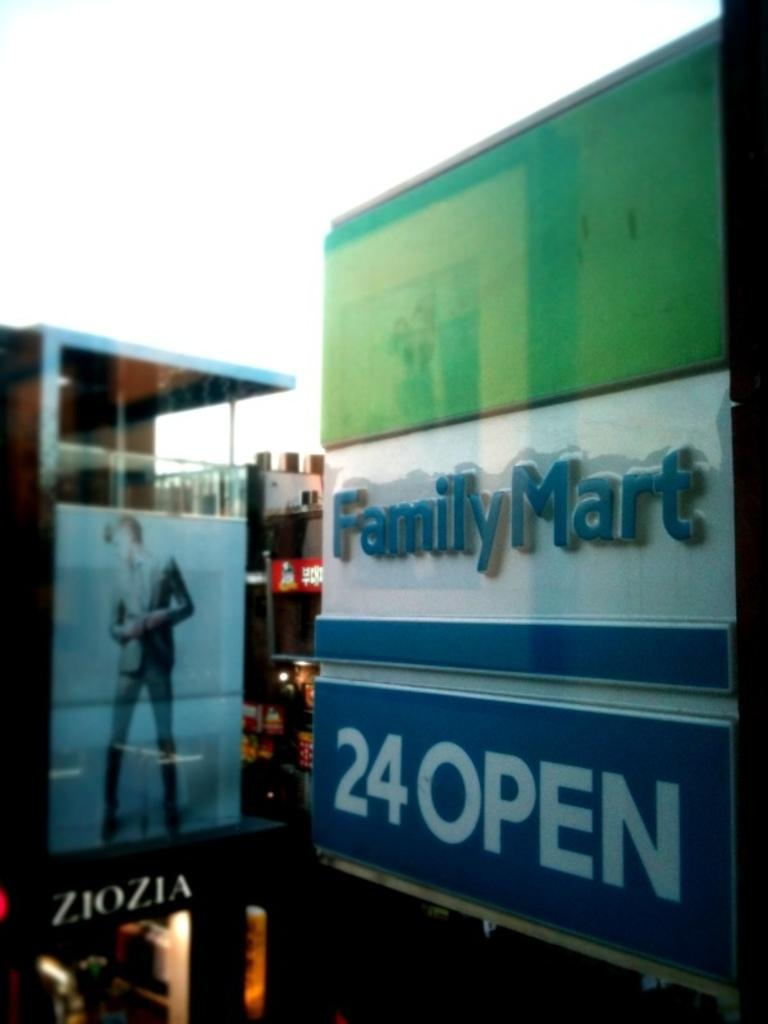Provide a one-sentence caption for the provided image. A store outlet sign for Family Mart which is also open 24 hours. 